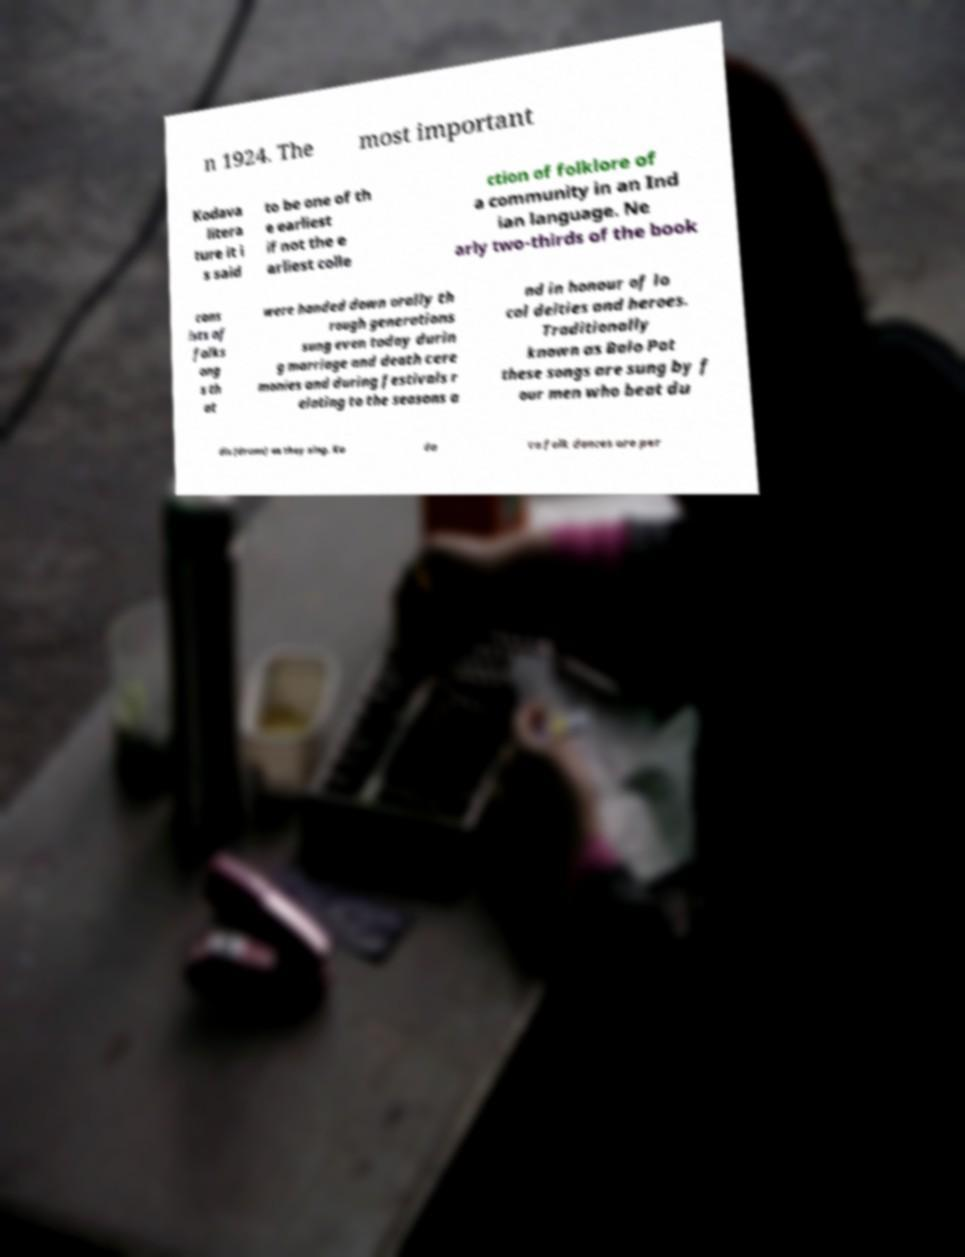Please read and relay the text visible in this image. What does it say? n 1924. The most important Kodava litera ture it i s said to be one of th e earliest if not the e arliest colle ction of folklore of a community in an Ind ian language. Ne arly two-thirds of the book cons ists of folks ong s th at were handed down orally th rough generations sung even today durin g marriage and death cere monies and during festivals r elating to the seasons a nd in honour of lo cal deities and heroes. Traditionally known as Balo Pat these songs are sung by f our men who beat du dis (drums) as they sing. Ko da va folk dances are per 